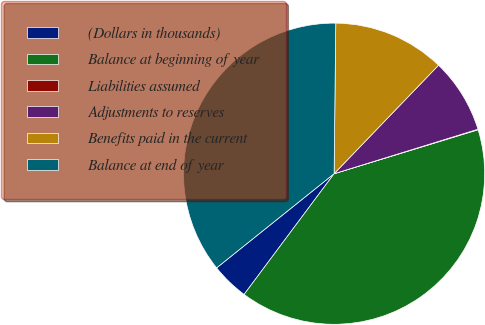Convert chart. <chart><loc_0><loc_0><loc_500><loc_500><pie_chart><fcel>(Dollars in thousands)<fcel>Balance at beginning of year<fcel>Liabilities assumed<fcel>Adjustments to reserves<fcel>Benefits paid in the current<fcel>Balance at end of year<nl><fcel>4.05%<fcel>39.91%<fcel>0.06%<fcel>8.03%<fcel>12.02%<fcel>35.93%<nl></chart> 